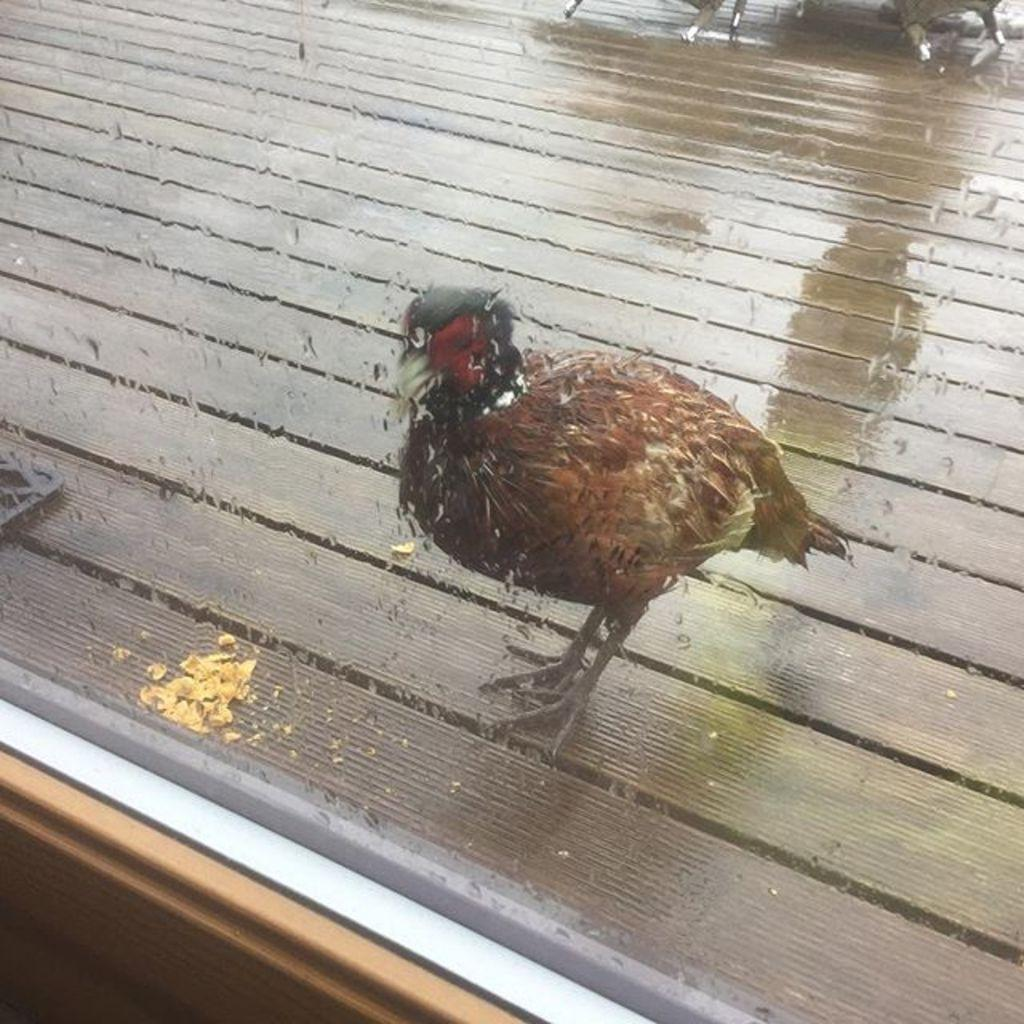What is located in the center of the image? There is a bird in the center of the image. What object can be seen in the image besides the bird? There is a board in the image. What type of surface is visible in the image? There is a floor visible in the image. What type of powder is being used by the bird in the image? There is no powder present in the image, and the bird is not using any powder. Is the bird wearing a skate in the image? There is no skate present in the image, and the bird is not wearing any skate. 